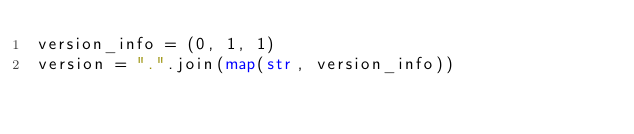<code> <loc_0><loc_0><loc_500><loc_500><_Python_>version_info = (0, 1, 1)
version = ".".join(map(str, version_info))
</code> 